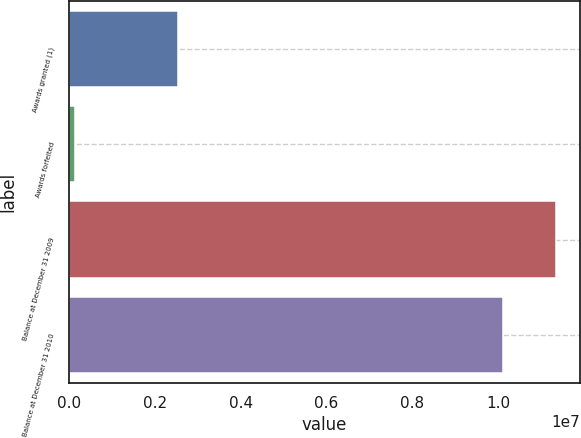<chart> <loc_0><loc_0><loc_500><loc_500><bar_chart><fcel>Awards granted (1)<fcel>Awards forfeited<fcel>Balance at December 31 2009<fcel>Balance at December 31 2010<nl><fcel>2.541e+06<fcel>146151<fcel>1.13498e+07<fcel>1.01065e+07<nl></chart> 